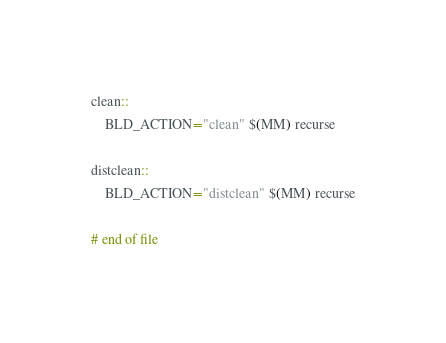Convert code to text. <code><loc_0><loc_0><loc_500><loc_500><_ObjectiveC_>
clean::
	BLD_ACTION="clean" $(MM) recurse

distclean::
	BLD_ACTION="distclean" $(MM) recurse

# end of file
</code> 